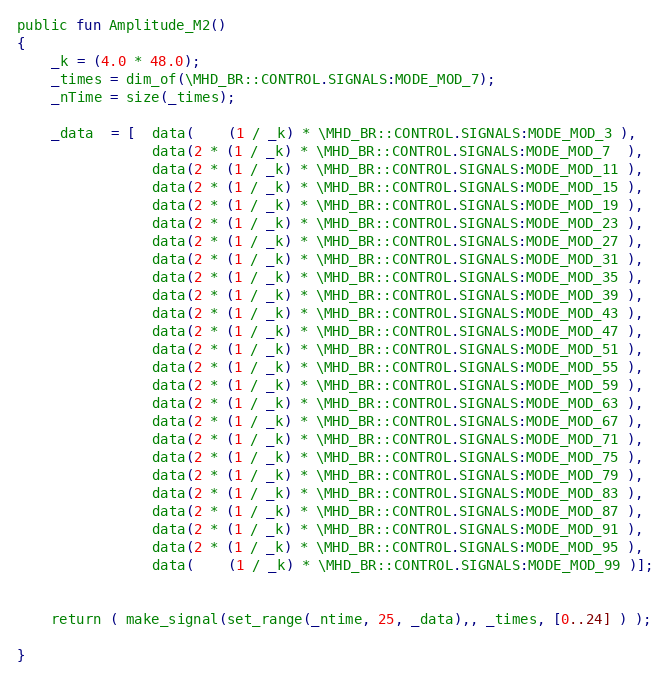<code> <loc_0><loc_0><loc_500><loc_500><_SML_>public fun Amplitude_M2()
{
    _k = (4.0 * 48.0);
	_times = dim_of(\MHD_BR::CONTROL.SIGNALS:MODE_MOD_7);
	_nTime = size(_times);
	
	_data  = [  data(    (1 / _k) * \MHD_BR::CONTROL.SIGNALS:MODE_MOD_3 ),
			    data(2 * (1 / _k) * \MHD_BR::CONTROL.SIGNALS:MODE_MOD_7  ),
			    data(2 * (1 / _k) * \MHD_BR::CONTROL.SIGNALS:MODE_MOD_11 ),
				data(2 * (1 / _k) * \MHD_BR::CONTROL.SIGNALS:MODE_MOD_15 ),
				data(2 * (1 / _k) * \MHD_BR::CONTROL.SIGNALS:MODE_MOD_19 ),
				data(2 * (1 / _k) * \MHD_BR::CONTROL.SIGNALS:MODE_MOD_23 ),
				data(2 * (1 / _k) * \MHD_BR::CONTROL.SIGNALS:MODE_MOD_27 ),
				data(2 * (1 / _k) * \MHD_BR::CONTROL.SIGNALS:MODE_MOD_31 ),
				data(2 * (1 / _k) * \MHD_BR::CONTROL.SIGNALS:MODE_MOD_35 ),
				data(2 * (1 / _k) * \MHD_BR::CONTROL.SIGNALS:MODE_MOD_39 ),
				data(2 * (1 / _k) * \MHD_BR::CONTROL.SIGNALS:MODE_MOD_43 ),
				data(2 * (1 / _k) * \MHD_BR::CONTROL.SIGNALS:MODE_MOD_47 ),
				data(2 * (1 / _k) * \MHD_BR::CONTROL.SIGNALS:MODE_MOD_51 ),
				data(2 * (1 / _k) * \MHD_BR::CONTROL.SIGNALS:MODE_MOD_55 ),
				data(2 * (1 / _k) * \MHD_BR::CONTROL.SIGNALS:MODE_MOD_59 ),
				data(2 * (1 / _k) * \MHD_BR::CONTROL.SIGNALS:MODE_MOD_63 ),
				data(2 * (1 / _k) * \MHD_BR::CONTROL.SIGNALS:MODE_MOD_67 ),
				data(2 * (1 / _k) * \MHD_BR::CONTROL.SIGNALS:MODE_MOD_71 ),
				data(2 * (1 / _k) * \MHD_BR::CONTROL.SIGNALS:MODE_MOD_75 ),
				data(2 * (1 / _k) * \MHD_BR::CONTROL.SIGNALS:MODE_MOD_79 ),
				data(2 * (1 / _k) * \MHD_BR::CONTROL.SIGNALS:MODE_MOD_83 ),
				data(2 * (1 / _k) * \MHD_BR::CONTROL.SIGNALS:MODE_MOD_87 ),
				data(2 * (1 / _k) * \MHD_BR::CONTROL.SIGNALS:MODE_MOD_91 ),
				data(2 * (1 / _k) * \MHD_BR::CONTROL.SIGNALS:MODE_MOD_95 ),
				data(    (1 / _k) * \MHD_BR::CONTROL.SIGNALS:MODE_MOD_99 )];
	
				
	return ( make_signal(set_range(_ntime, 25, _data),, _times, [0..24] ) );
				
}</code> 